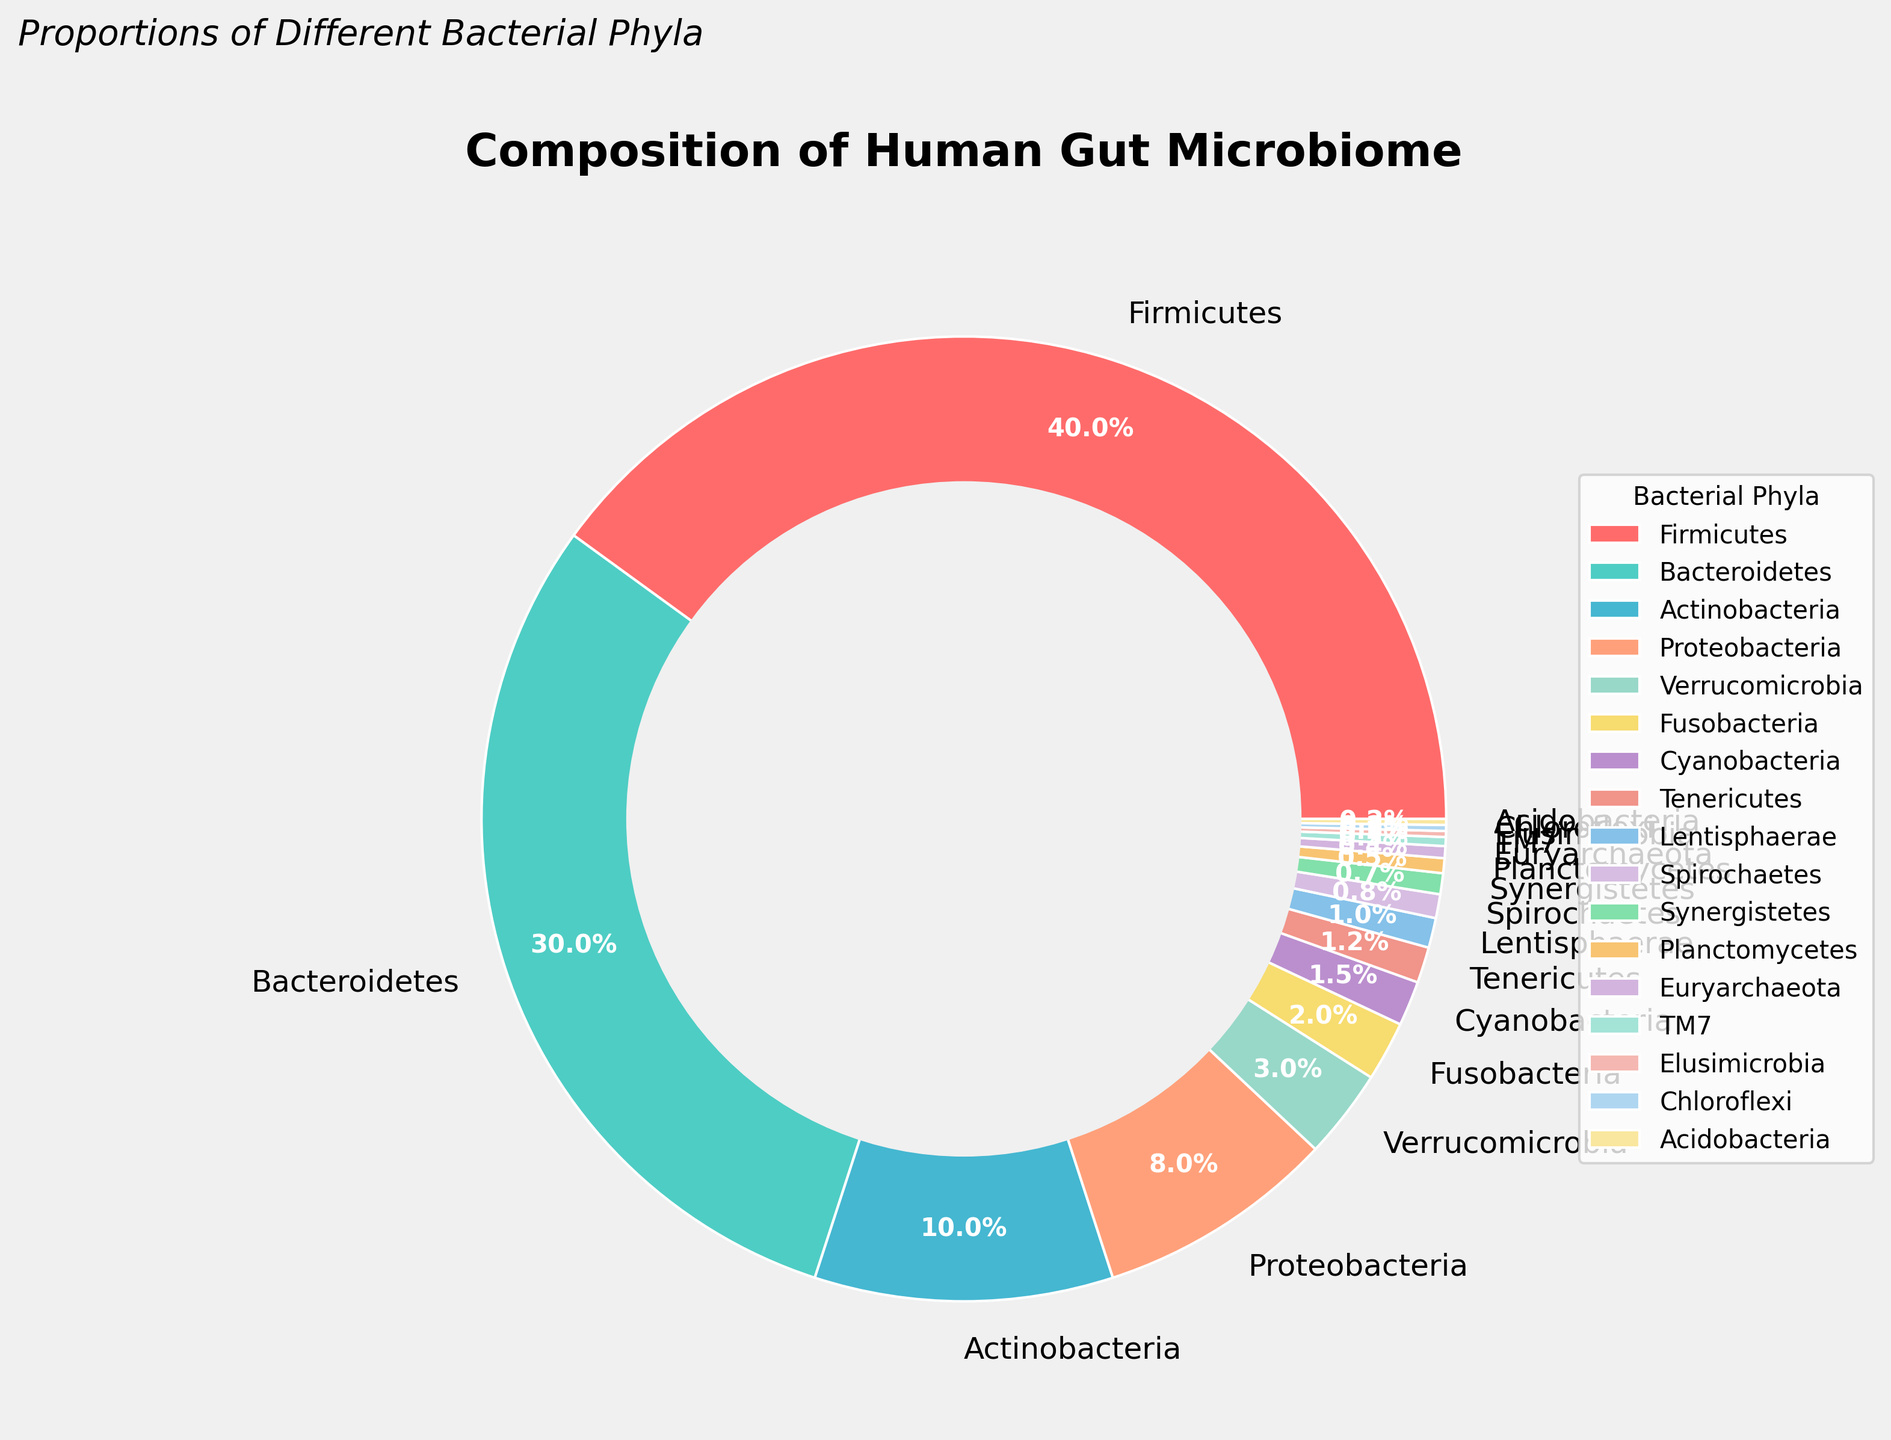What percentage of the human gut microbiome is represented by Proteobacteria and Verrucomicrobia combined? To find the combined percentage, add the percentages of Proteobacteria (8%) and Verrucomicrobia (3%). The combined percentage is 8% + 3% = 11%.
Answer: 11% Which bacterial phylum has the smallest proportion in the human gut microbiome? By looking at the chart, the phylum with the smallest proportion is Elusimicrobia, which has a percentage of 0.2%.
Answer: Elusimicrobia How does the proportion of Firmicutes compare to that of Bacteroidetes? The chart shows that Firmicutes represent 40% of the microbiome, while Bacteroidetes represent 30%. Since 40% is greater than 30%, Firmicutes have a higher proportion than Bacteroidetes.
Answer: Firmicutes have a higher proportion If you were to combine the proportions of Actinobacteria, Fusobacteria, Cyanobacteria, and Tenericutes, what would be the total percentage? Sum the percentages of Actinobacteria (10%), Fusobacteria (2%), Cyanobacteria (1.5%), and Tenericutes (1.2%). The total percentage is 10% + 2% + 1.5% + 1.2% = 14.7%.
Answer: 14.7% Which color represents Firmicutes in the pie chart? By looking at the pie chart, the color representing Firmicutes is the first slice of the pie, which appears to be red.
Answer: Red Is the proportion of Cyanobacteria greater than that of Spirochaetes? The chart indicates Cyanobacteria have a percentage of 1.5% and Spirochaetes have a percentage of 0.8%. Since 1.5% is greater than 0.8%, Cyanobacteria have a higher proportion than Spirochaetes.
Answer: Yes What is the second most abundant phylum in the human gut microbiome according to the chart? By examining the proportions, the second most abundant phylum is Bacteroidetes, which represents 30% of the microbiome, second only to Firmicutes.
Answer: Bacteroidetes How much larger is the proportion of Firmicutes compared to Actinobacteria? Firmicutes represent 40% of the microbiome, while Actinobacteria represent 10%. The difference is 40% - 10% = 30%.
Answer: 30% If you add together the percentages of Synergistetes, Planctomycetes, and Euryarchaeota, what fraction of the human gut microbiome do they represent? Sum the percentages: Synergistetes (0.7%), Planctomycetes (0.5%), and Euryarchaeota (0.4%). The total is 0.7% + 0.5% + 0.4% = 1.6%. As a fraction this is 1.6/100 = 0.016.
Answer: 0.016 